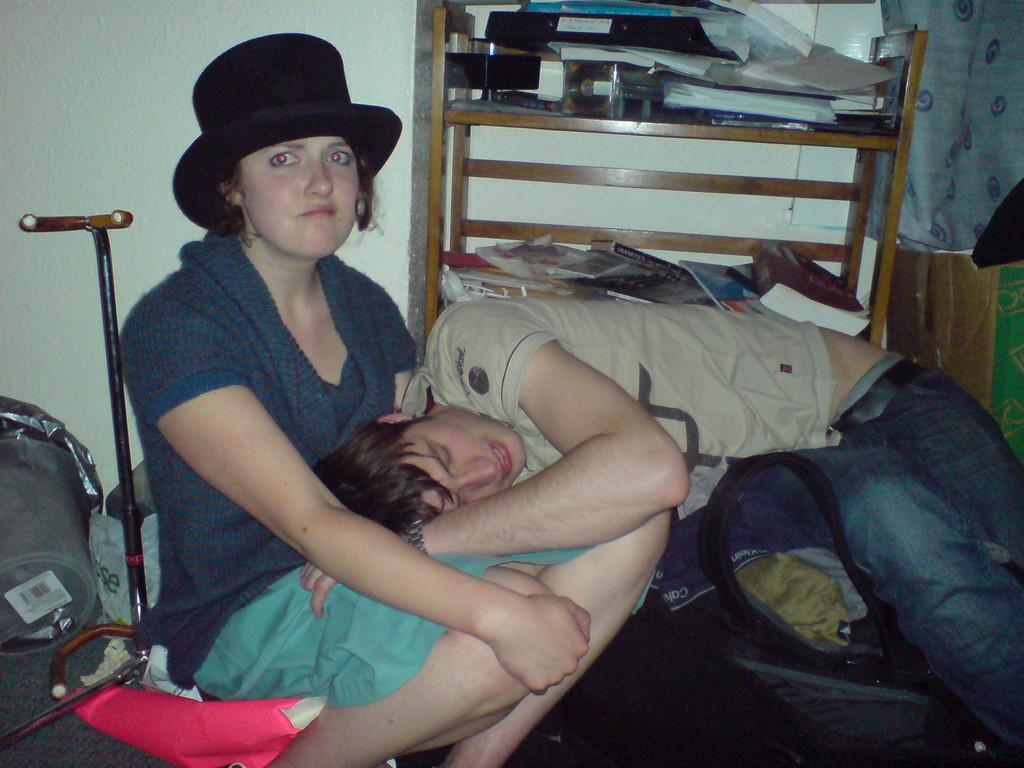In one or two sentences, can you explain what this image depicts? In this picture there is a woman sitting and there is a man lying. On the left side of the image there is an object and it looks like a bag. At the back there are objects and there are books in the cupboard. On the right side of there is a cloth and there is a cardboard box. At the back there is wall. 